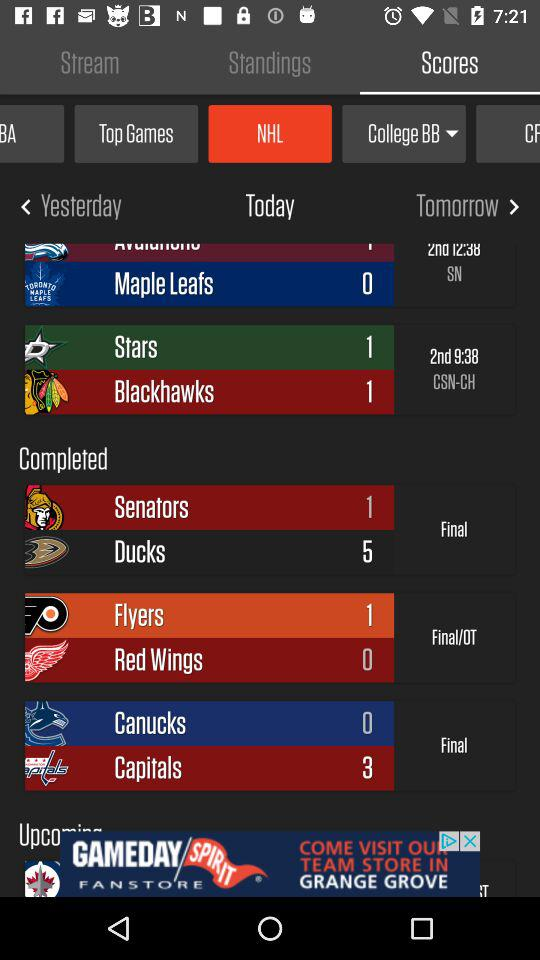What is the score of "Flyers" and "Red Wings"? The scores of "Flyers" and "Red Wings" are 1 and 0, respectively. 